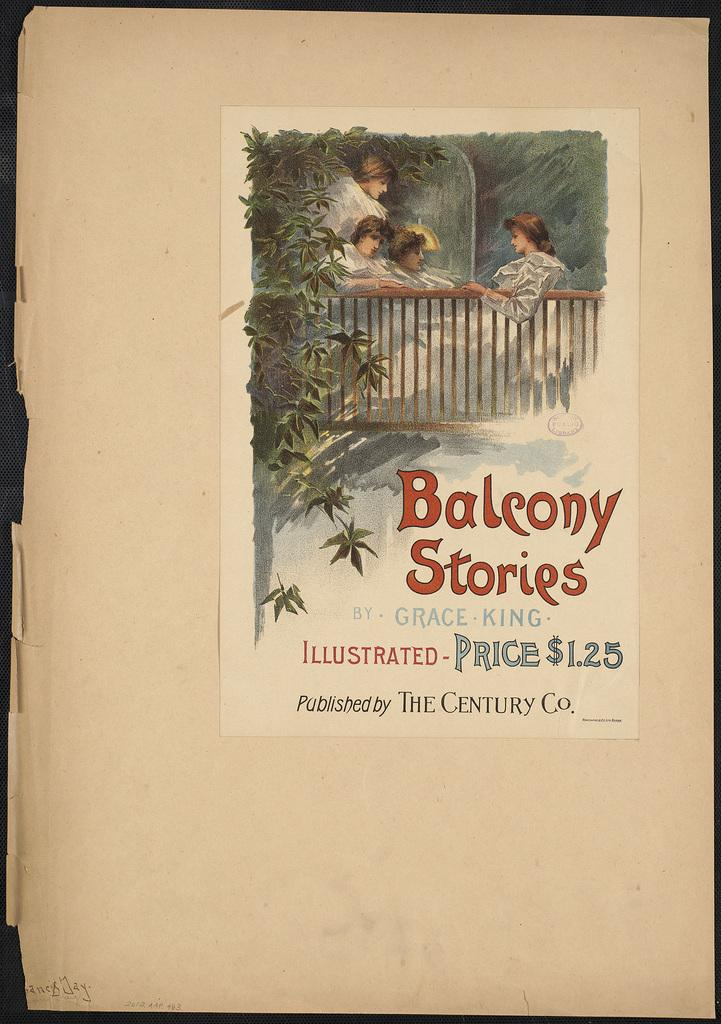<image>
Render a clear and concise summary of the photo. An antique book titled Balcony Stories by Grace King. 